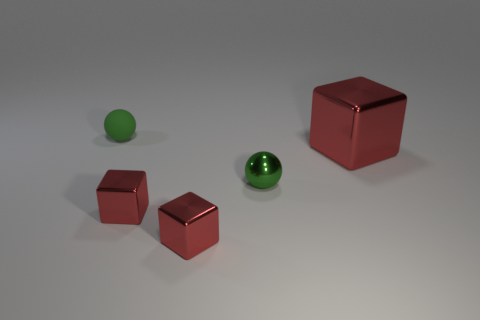Is the tiny matte thing the same color as the tiny shiny ball?
Offer a terse response. Yes. The metal thing on the right side of the tiny green metallic object is what color?
Keep it short and to the point. Red. What number of things are red objects to the right of the small shiny sphere or gray blocks?
Offer a terse response. 1. The rubber thing that is the same size as the green shiny object is what color?
Ensure brevity in your answer.  Green. Is the number of metal balls in front of the matte ball greater than the number of small matte cubes?
Give a very brief answer. Yes. There is a object that is behind the tiny green metal thing and right of the matte ball; what is its material?
Provide a short and direct response. Metal. Do the metal thing that is behind the green metallic thing and the ball behind the metallic sphere have the same color?
Make the answer very short. No. There is a green ball to the right of the green thing behind the green metal sphere; is there a metallic object that is right of it?
Offer a very short reply. Yes. Does the small green sphere left of the green metallic object have the same material as the big block?
Your answer should be compact. No. There is a shiny object that is the same shape as the green rubber object; what is its color?
Ensure brevity in your answer.  Green. 